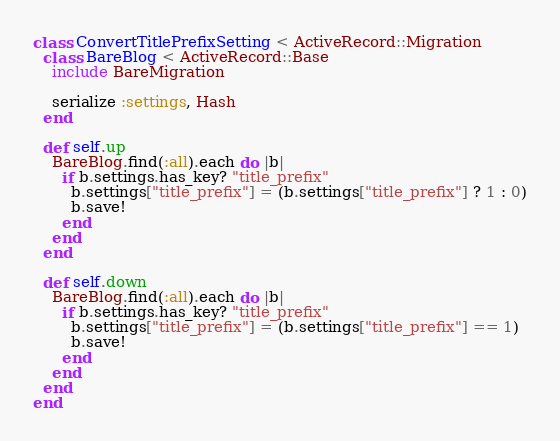<code> <loc_0><loc_0><loc_500><loc_500><_Ruby_>class ConvertTitlePrefixSetting < ActiveRecord::Migration
  class BareBlog < ActiveRecord::Base
    include BareMigration

    serialize :settings, Hash
  end

  def self.up
    BareBlog.find(:all).each do |b|
      if b.settings.has_key? "title_prefix"
        b.settings["title_prefix"] = (b.settings["title_prefix"] ? 1 : 0)
        b.save!
      end
    end
  end

  def self.down
    BareBlog.find(:all).each do |b|
      if b.settings.has_key? "title_prefix"
        b.settings["title_prefix"] = (b.settings["title_prefix"] == 1)
        b.save!
      end
    end
  end
end
</code> 